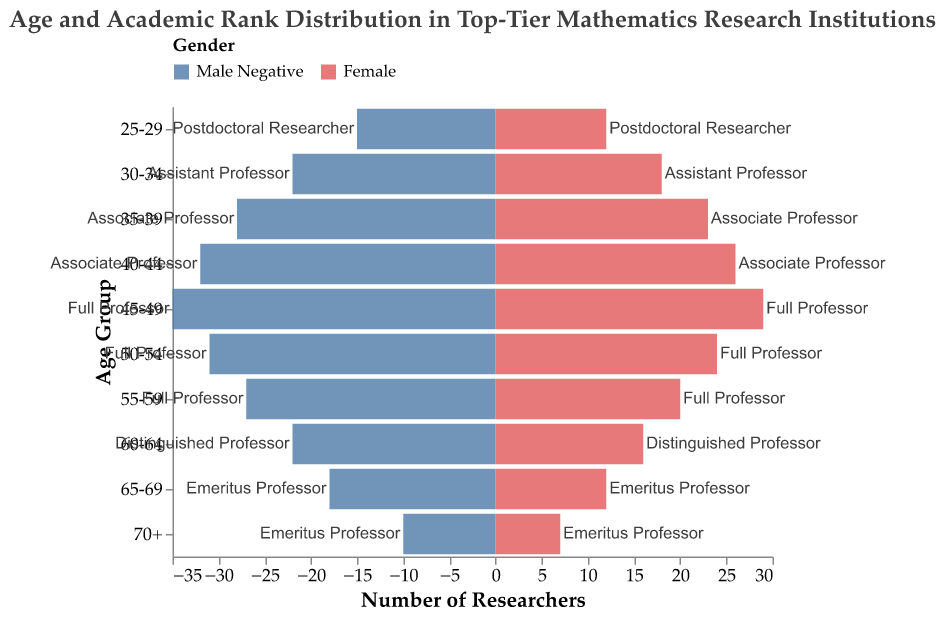What is the age group with the highest number of female researchers? Look at the female researchers column to identify the age group with the highest count. The age group 45-49 has the highest number of female researchers, which is 29.
Answer: 45-49 How many total researchers are in the 60-64 age group? Sum the number of male researchers and female researchers for the 60-64 age group. The sum is 22 (Male) + 16 (Female) = 38.
Answer: 38 Which academic rank appears in the 30-34 age group? By referring to the corresponding cell of the 30-34 age group, you will find the academic rank is Assistant Professor.
Answer: Assistant Professor Identify the gender and age group with the lowest number of researchers. From the plot, find the smallest value in either gender column and identify the age group. The Male 70+ group has the lowest number, which is 10.
Answer: Male in 70+ Compare the number of male and female researchers in the 50-54 age group. Which gender has more individuals, and by how much? Subtract the number of female researchers from the number of male researchers in the 50-54 age group. The difference is 31 - 24 = 7, with males having more individuals.
Answer: Males by 7 What is the average number of researchers in the 35-39 age group? Calculate the average by adding the male and female researchers and dividing by two. The sum is 28 (Male) + 23 (Female) = 51. The average is 51/2 = 25.5.
Answer: 25.5 Which age group has the highest number of full professors? Look at the number of researchers in the age groups identified as Full Professor (45-49, 50-54, 55-59). The 45-49 age group has 64 (35 Male + 29 Female).
Answer: 45-49 How does the number of postdoctoral researchers compare to distinguished professors in the 25-29 and 60-64 age groups, respectively? Compare the total number of postdoctoral researchers (15 Male + 12 Female = 27) with distinguished professors (22 Male + 16 Female = 38). Distinguished professors are higher by 11.
Answer: Distinguished professors by 11 